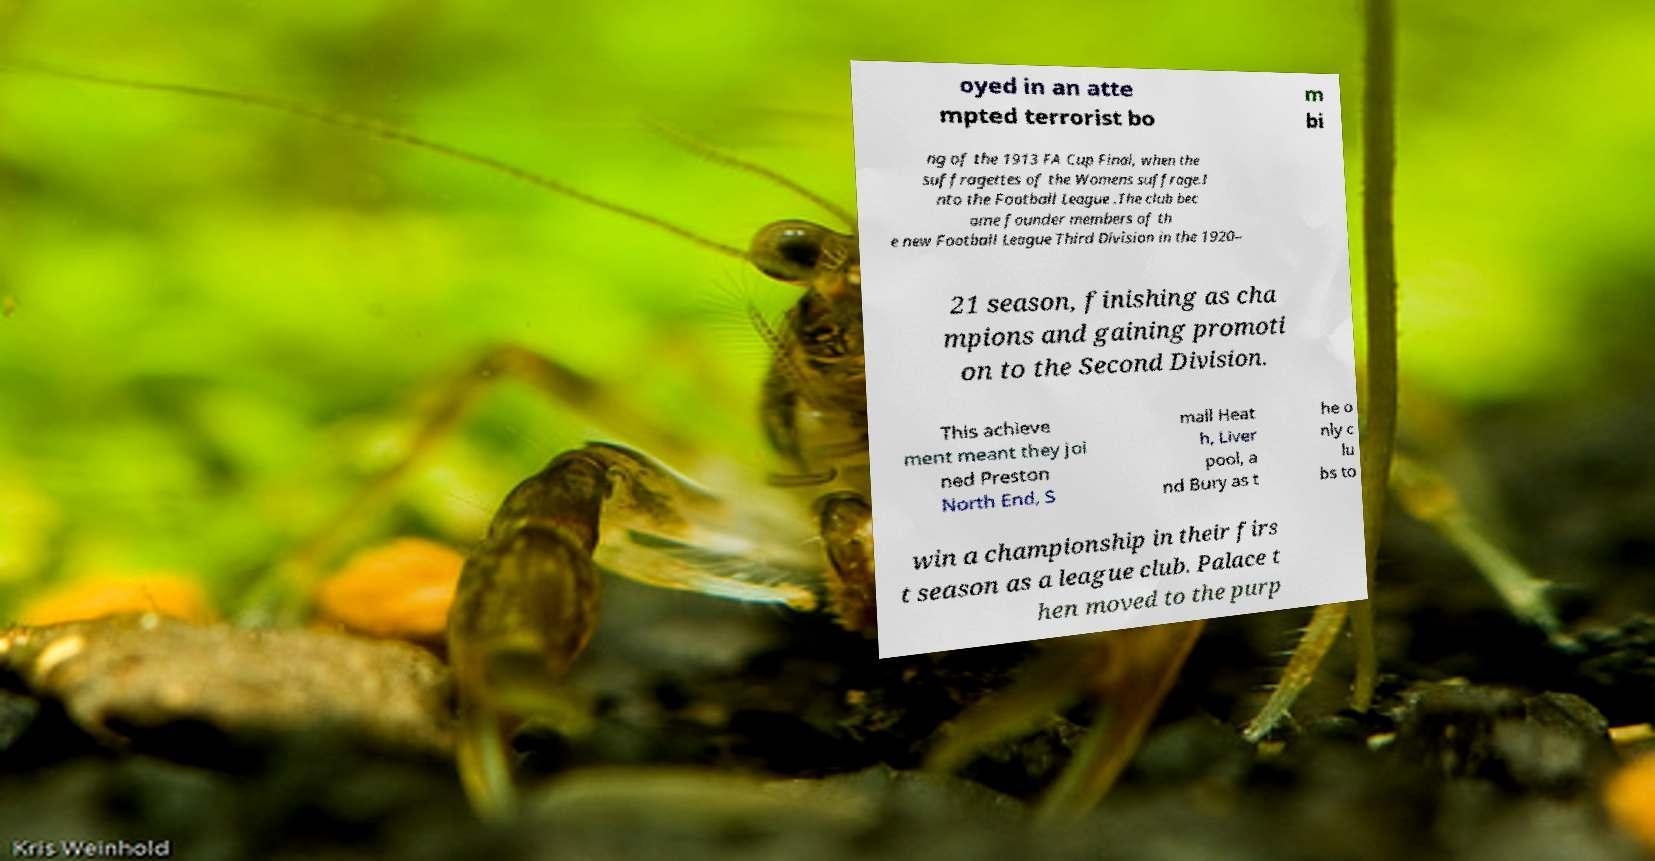Could you extract and type out the text from this image? oyed in an atte mpted terrorist bo m bi ng of the 1913 FA Cup Final, when the suffragettes of the Womens suffrage.I nto the Football League .The club bec ame founder members of th e new Football League Third Division in the 1920– 21 season, finishing as cha mpions and gaining promoti on to the Second Division. This achieve ment meant they joi ned Preston North End, S mall Heat h, Liver pool, a nd Bury as t he o nly c lu bs to win a championship in their firs t season as a league club. Palace t hen moved to the purp 